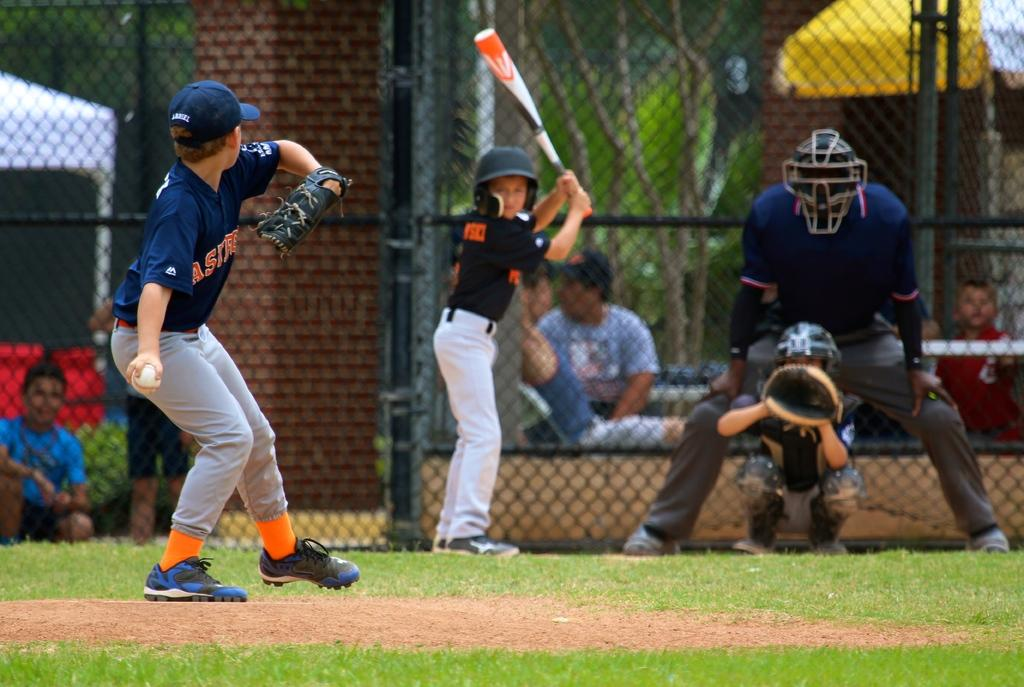<image>
Summarize the visual content of the image. a boy with an Astros jersey on getting ready to pitch 